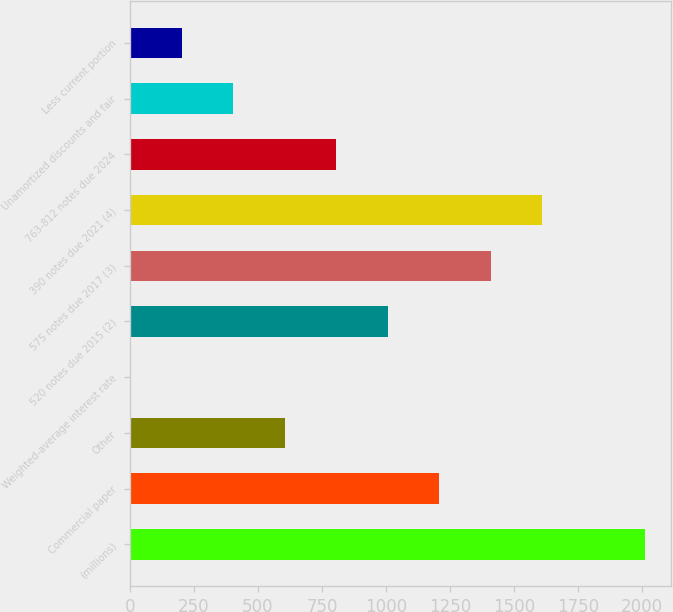<chart> <loc_0><loc_0><loc_500><loc_500><bar_chart><fcel>(millions)<fcel>Commercial paper<fcel>Other<fcel>Weighted-average interest rate<fcel>520 notes due 2015 (2)<fcel>575 notes due 2017 (3)<fcel>390 notes due 2021 (4)<fcel>763-812 notes due 2024<fcel>Unamortized discounts and fair<fcel>Less current portion<nl><fcel>2013<fcel>1208.08<fcel>604.39<fcel>0.7<fcel>1006.85<fcel>1409.31<fcel>1610.54<fcel>805.62<fcel>403.16<fcel>201.93<nl></chart> 